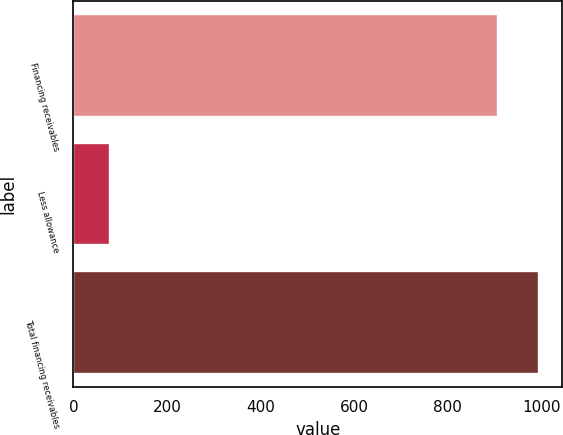Convert chart. <chart><loc_0><loc_0><loc_500><loc_500><bar_chart><fcel>Financing receivables<fcel>Less allowance<fcel>Total financing receivables<nl><fcel>908<fcel>79<fcel>995.1<nl></chart> 